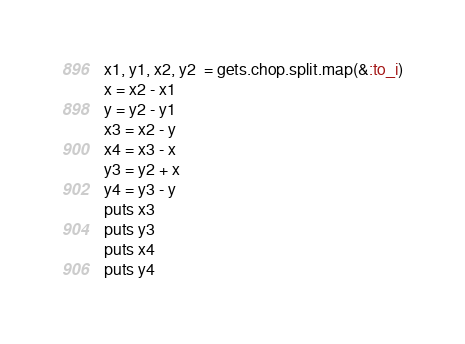Convert code to text. <code><loc_0><loc_0><loc_500><loc_500><_Ruby_>x1, y1, x2, y2  = gets.chop.split.map(&:to_i)
x = x2 - x1
y = y2 - y1
x3 = x2 - y
x4 = x3 - x
y3 = y2 + x
y4 = y3 - y
puts x3
puts y3
puts x4
puts y4
</code> 